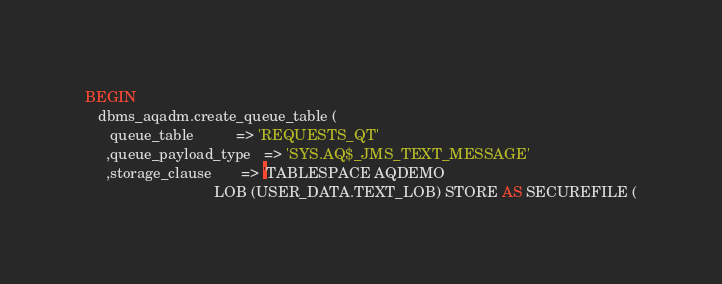<code> <loc_0><loc_0><loc_500><loc_500><_SQL_>BEGIN
   dbms_aqadm.create_queue_table (
      queue_table          => 'REQUESTS_QT'
     ,queue_payload_type   => 'SYS.AQ$_JMS_TEXT_MESSAGE'
     ,storage_clause       => 'TABLESPACE AQDEMO
                               LOB (USER_DATA.TEXT_LOB) STORE AS SECUREFILE (</code> 